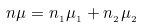<formula> <loc_0><loc_0><loc_500><loc_500>n \mu = n _ { _ { 1 } } \mu _ { _ { 1 } } + n _ { _ { 2 } } \mu _ { _ { 2 } }</formula> 